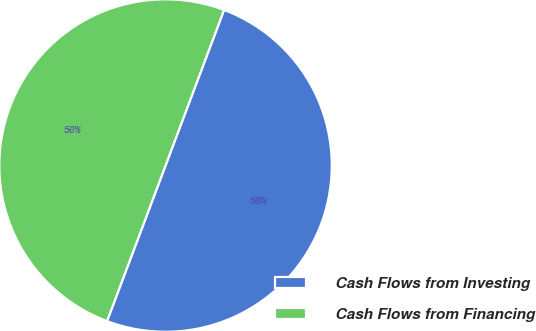Convert chart. <chart><loc_0><loc_0><loc_500><loc_500><pie_chart><fcel>Cash Flows from Investing<fcel>Cash Flows from Financing<nl><fcel>50.0%<fcel>50.0%<nl></chart> 